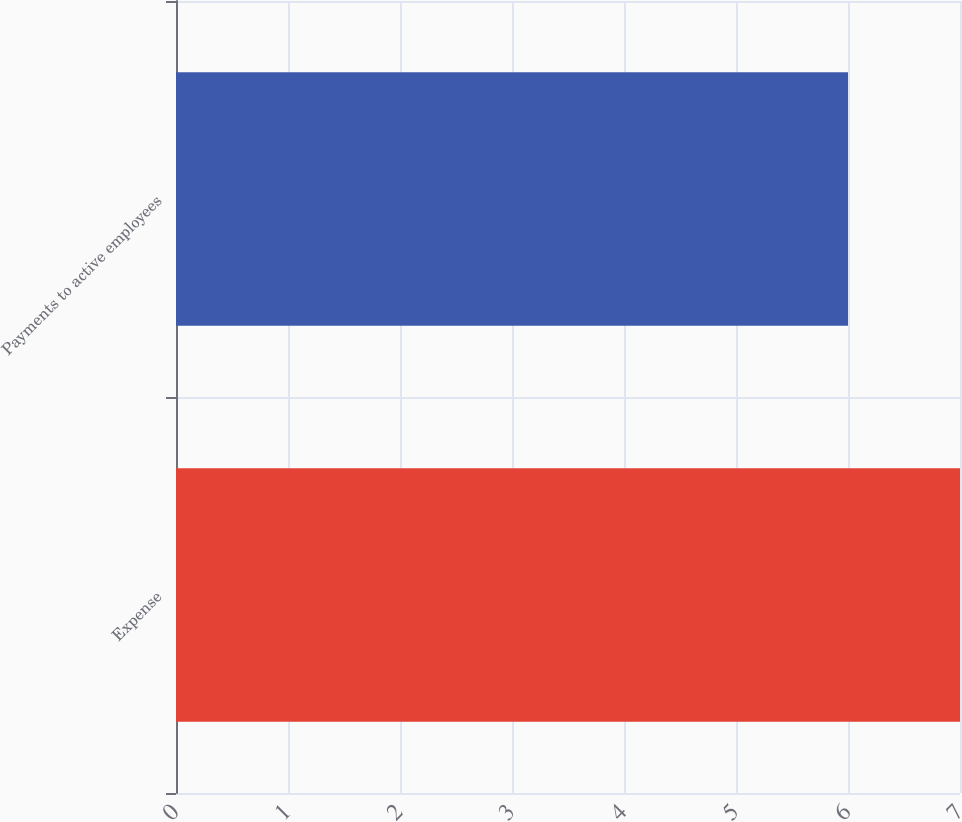Convert chart. <chart><loc_0><loc_0><loc_500><loc_500><bar_chart><fcel>Expense<fcel>Payments to active employees<nl><fcel>7<fcel>6<nl></chart> 